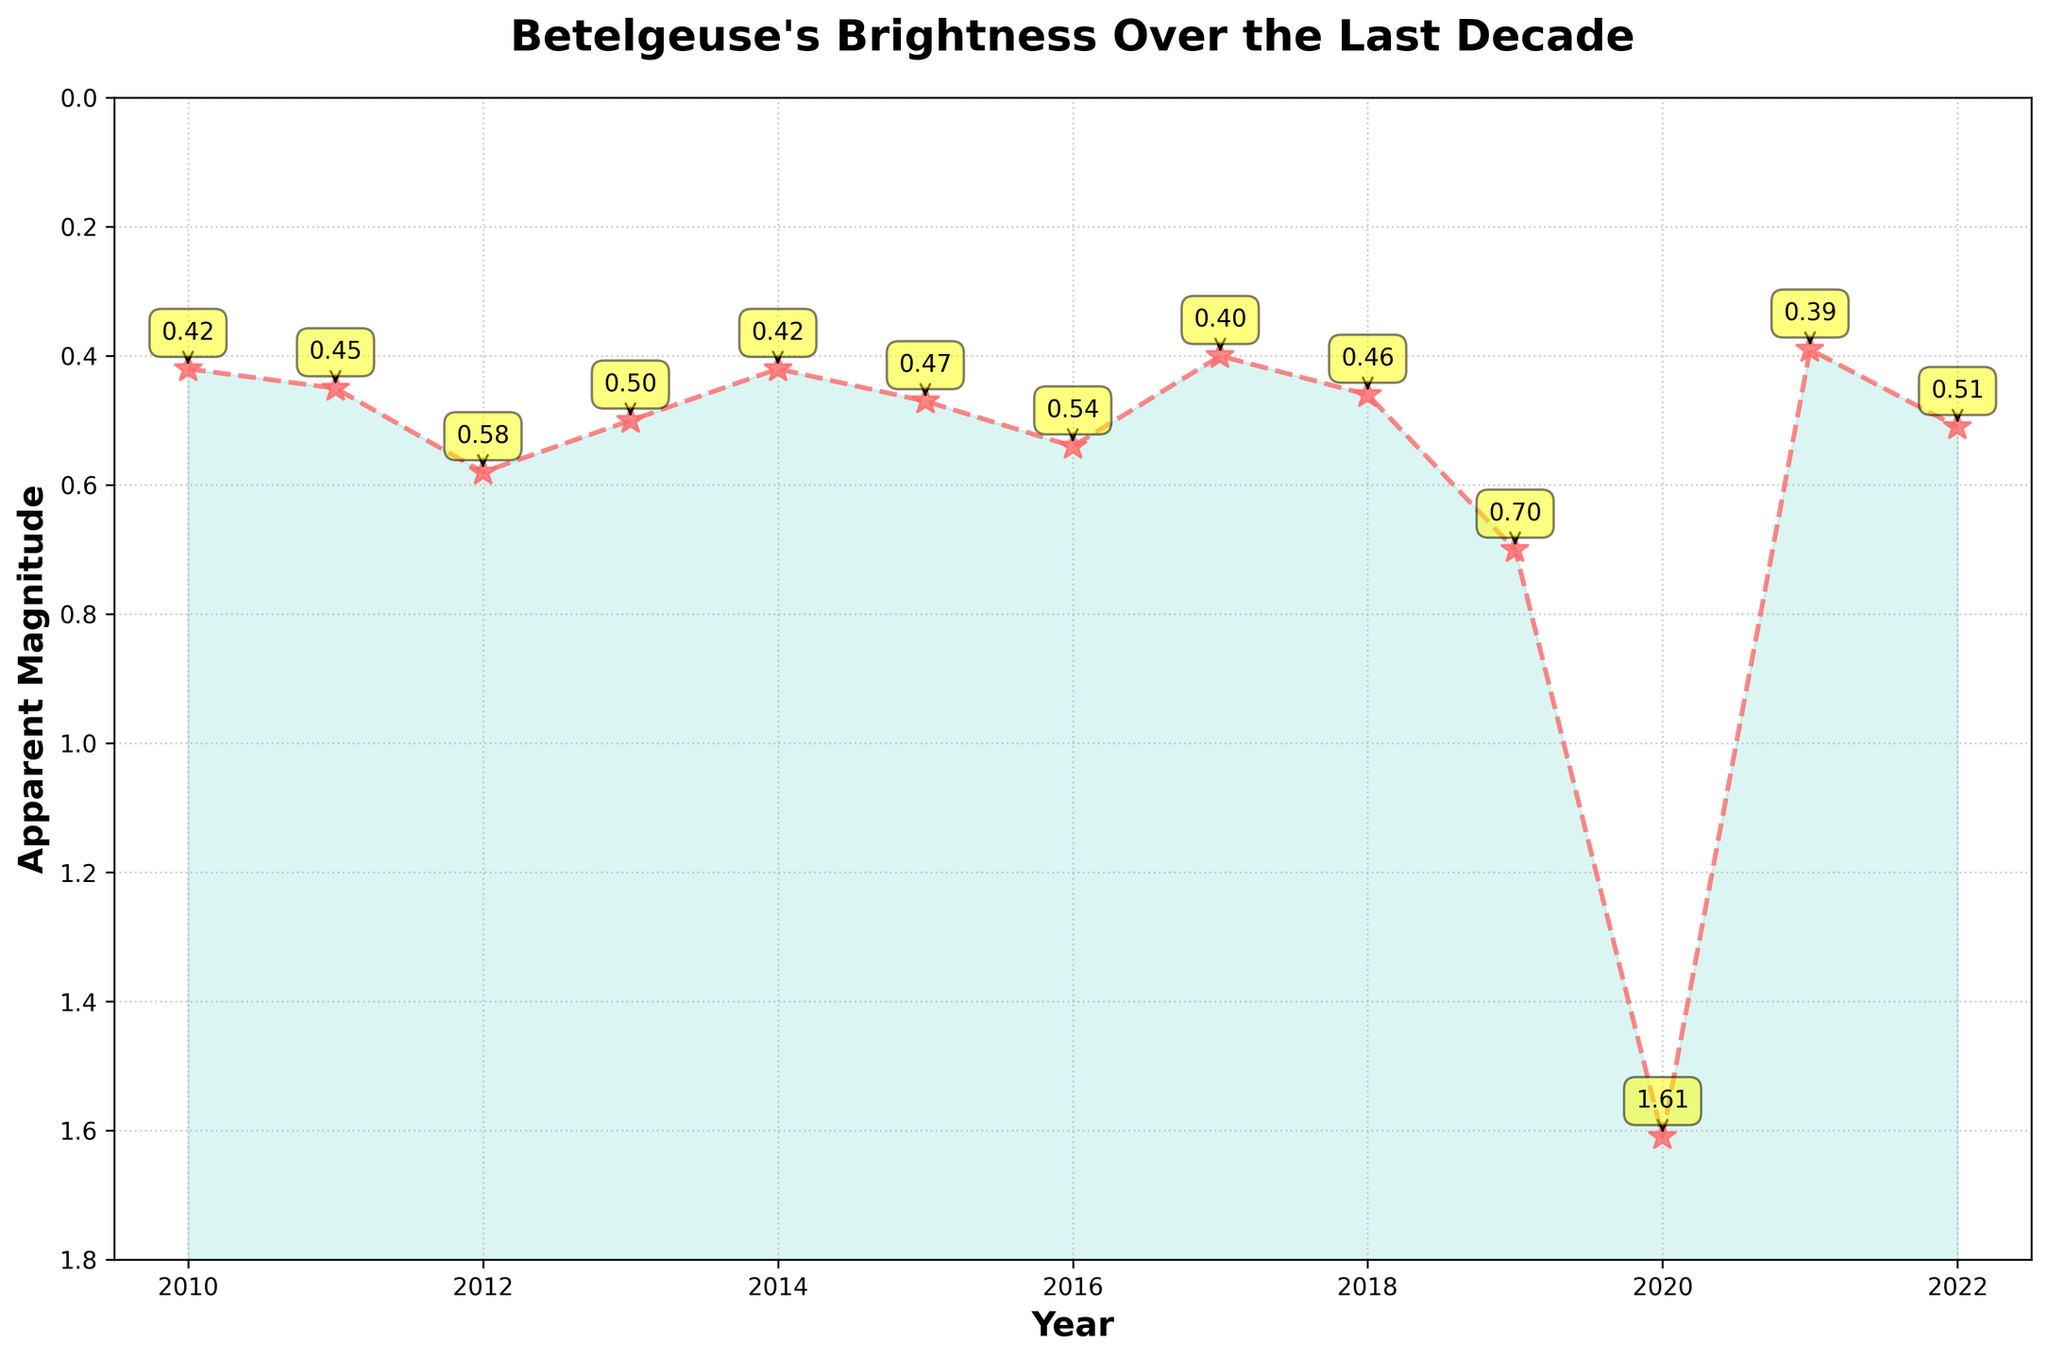What's the highest apparent magnitude recorded in the last decade? To find the highest apparent magnitude, look for the highest point on the y-axis of the plot. In 2020, the apparent magnitude reached 1.61.
Answer: 1.61 What's the average apparent magnitude over the last decade? Sum all the apparent magnitudes from 2010 to 2022 and divide by the number of years. (0.42 + 0.45 + 0.58 + 0.50 + 0.42 + 0.47 + 0.54 + 0.40 + 0.46 + 0.70 + 1.61 + 0.39 + 0.51) / 13 ≈ 0.53
Answer: 0.53 Which year experienced the sharpest increase in apparent magnitude from the previous year? Compare the differences in apparent magnitudes between consecutive years and identify the largest difference. The largest increase was from 2019 (0.70) to 2020 (1.61), with a difference of 0.91.
Answer: 2020 Which year experienced the greatest drop in apparent magnitude from the previous year? Compare the differences in apparent magnitudes between consecutive years and identify the largest decrease. The greatest drop occurred from 2020 (1.61) to 2021 (0.39), with a difference of -1.22.
Answer: 2021 How does the brightness in 2019 compare to 2020? Compare the apparent magnitudes of 2019 and 2020. In 2019, it was 0.70, and in 2020, it jumped to 1.61, indicating a decrease in brightness.
Answer: 2019 was brighter What's the trend in Betelgeuse's brightness from 2018 to 2020? Observe the apparent magnitudes for 2018, 2019, and 2020 on the plot. In 2018, it was 0.46, in 2019 it was 0.70, and in 2020 it was 1.61, indicating a significant decrease in brightness over these years.
Answer: Decreasing brightness What is the overall trend in Betelgeuse's brightness over the last decade? Look at the apparent magnitudes from 2010 to 2022. Despite fluctuations, there is generally no consistent upward or downward trend across the entire decade, but there was a notable brightening after 2020.
Answer: Fluctuating with significant variation In which year did Betelgeuse have its lowest apparent magnitude (brightest)? Find the lowest point on the y-axis. The lowest apparent magnitude (brightest) was in 2017, at 0.40.
Answer: 2017 